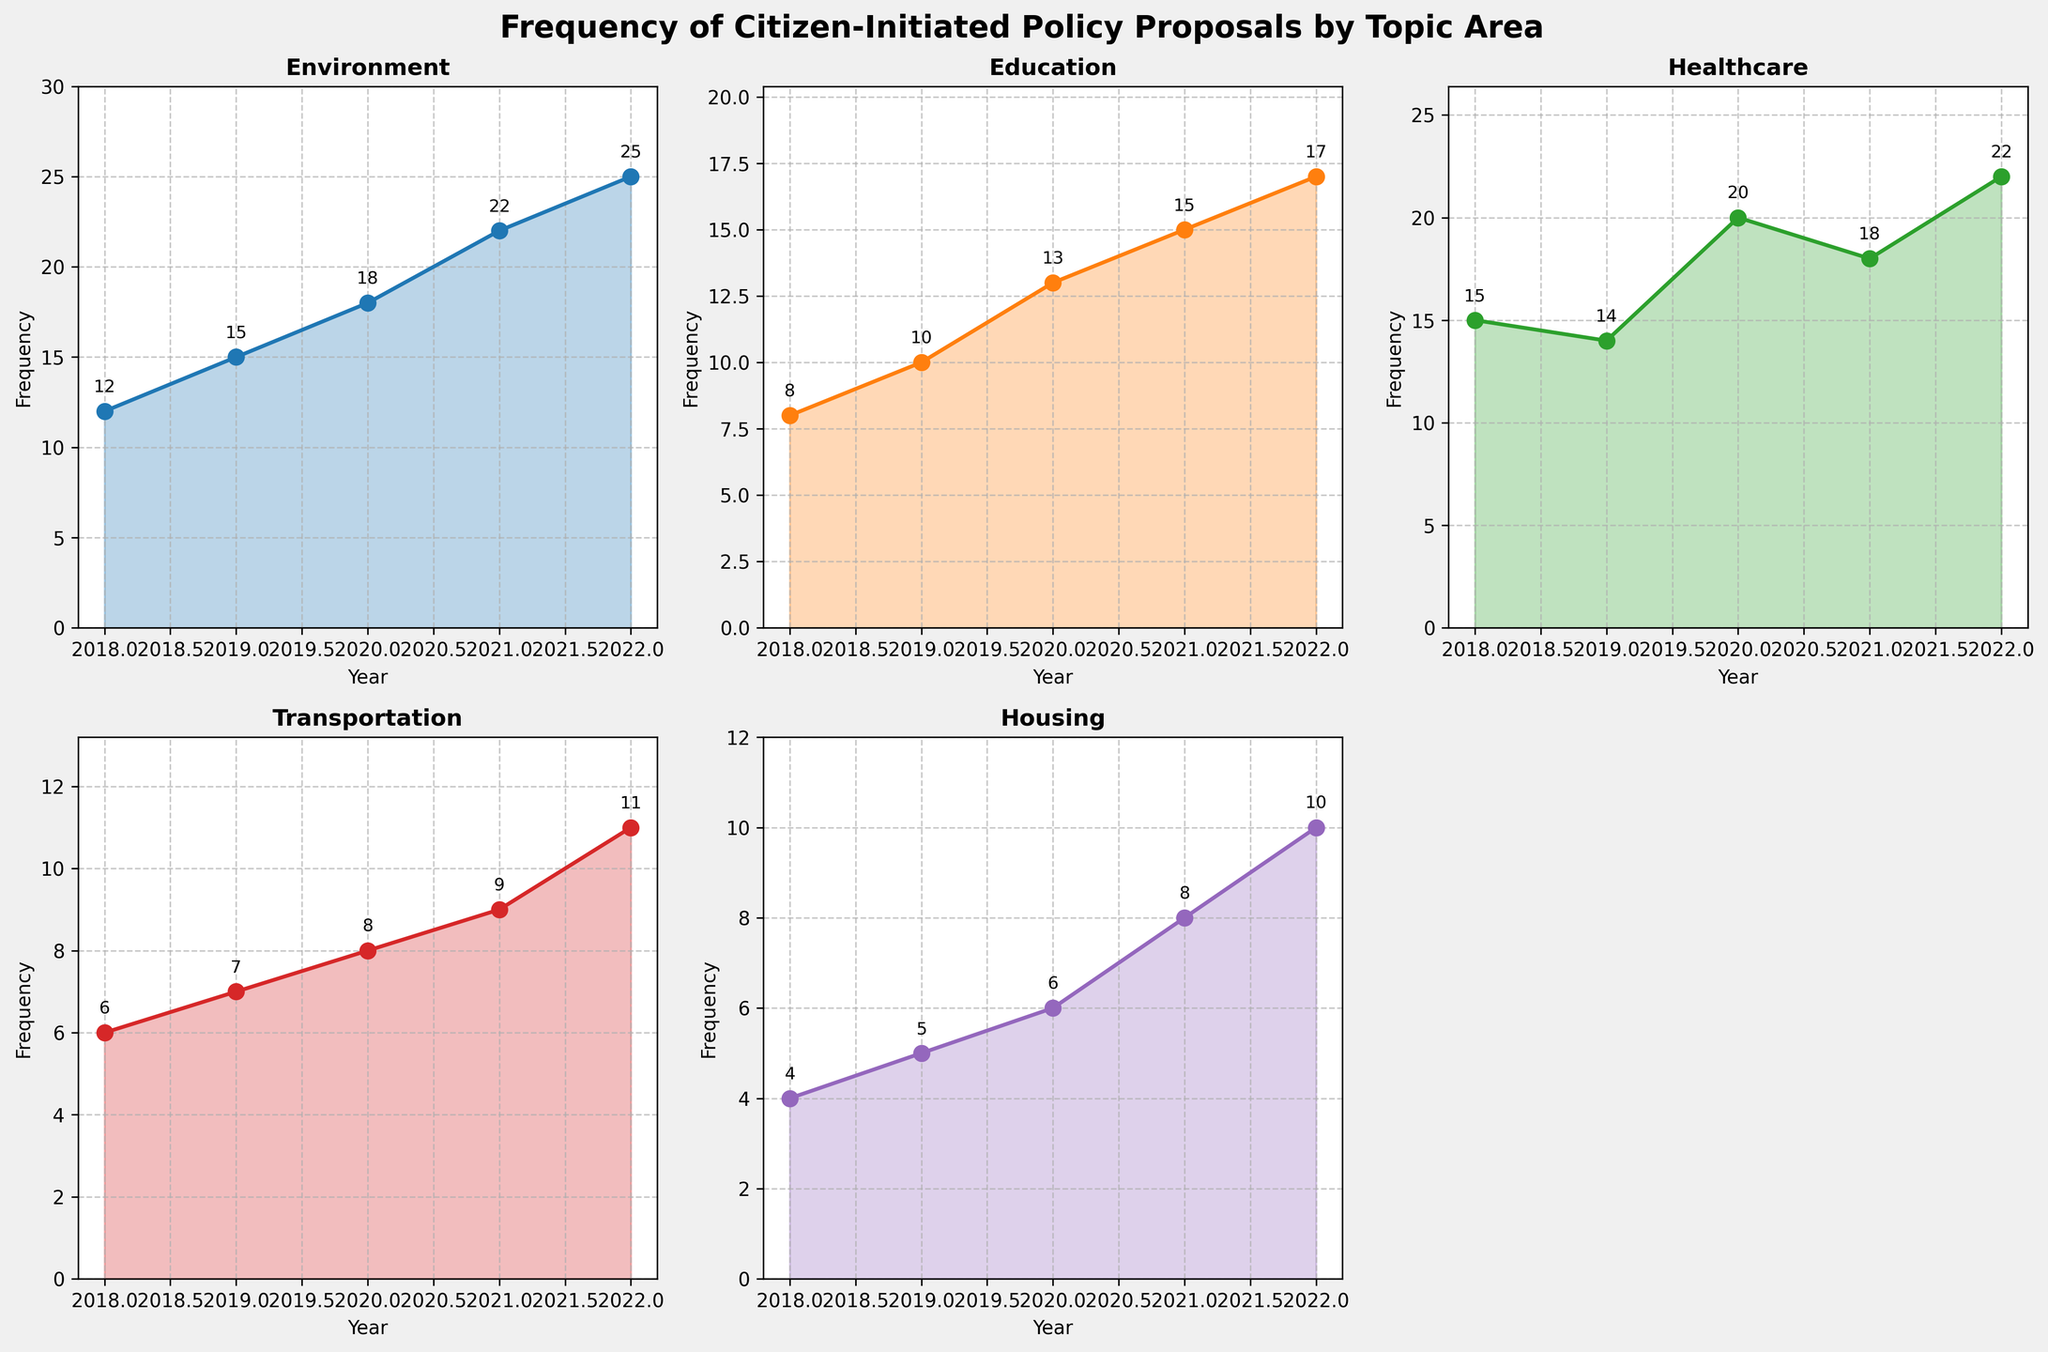What is the title of the figure? The title is located at the top center of the figure and gives a summary of what the figure represents.
Answer: Frequency of Citizen-Initiated Policy Proposals by Topic Area Which topic had the highest frequency of policy proposals in 2022? By examining the plot for each topic area, find the highest data point for the year 2022. The Environment topic shows the highest value.
Answer: Environment How did the frequency of healthcare proposals change from 2018 to 2022? Look at the plot for Healthcare and note the values for 2018 and 2022. Subtract the value for 2018 from the value for 2022. The frequency increased from 15 to 22.
Answer: Increased by 7 What's the average frequency of citizen-initiated proposals for education between 2018 and 2022? Add the yearly values of education proposals for all years (8, 10, 13, 15, 17) and divide by the number of years (5). The calculation is (8+10+13+15+17)/5.
Answer: 12.6 Compare the trends of environment and transportation. Which one shows a steeper increase? Observe the slopes of the lines for environment and transportation. The environment's frequency values increase from 12 to 25, and transportation's increase from 6 to 11. The environment has a steeper increase.
Answer: Environment During which year did housing have the lowest frequency of proposals? Look at the plot for Housing and identify the lowest plotted value along the x-axis. The value is lowest in 2018.
Answer: 2018 What is the total frequency of policy proposals for the year 2020 across all topic areas? Sum the individual topic's frequencies for the year 2020 (18, 13, 20, 8, 6). The calculation is 18 + 13 + 20 + 8 + 6.
Answer: 65 Which year's education proposals saw the highest increase from the previous year? Examine the yearly values for education proposals and identify the year with the highest numeric difference from the prior year. The largest increase is from 2019 to 2020 (from 10 to 13).
Answer: 2020 What are the color codes representing healthcare and housing topics? Check the colors in the subplots representing Healthcare and Housing. Healthcare is represented in green (#2ca02c) and Housing in purple (#9467bd).
Answer: Green and Purple 